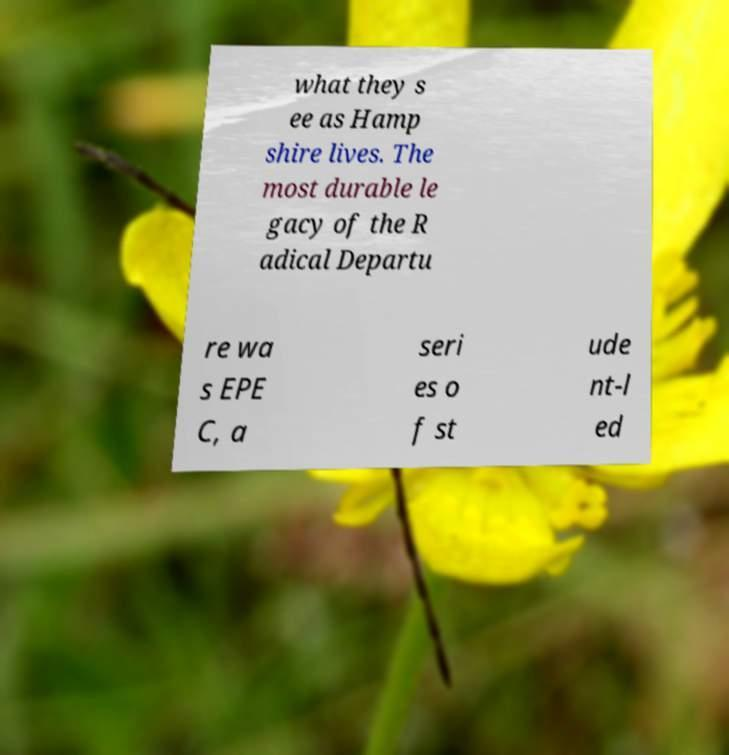Can you read and provide the text displayed in the image?This photo seems to have some interesting text. Can you extract and type it out for me? what they s ee as Hamp shire lives. The most durable le gacy of the R adical Departu re wa s EPE C, a seri es o f st ude nt-l ed 